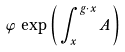Convert formula to latex. <formula><loc_0><loc_0><loc_500><loc_500>\varphi \, \exp \left ( \, \int _ { x } ^ { g \cdot x } A \, \right )</formula> 